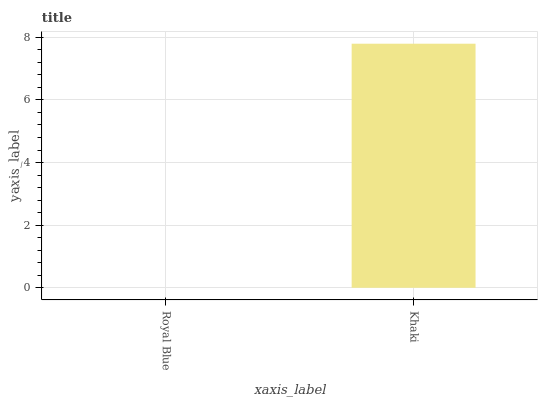Is Royal Blue the minimum?
Answer yes or no. Yes. Is Khaki the maximum?
Answer yes or no. Yes. Is Khaki the minimum?
Answer yes or no. No. Is Khaki greater than Royal Blue?
Answer yes or no. Yes. Is Royal Blue less than Khaki?
Answer yes or no. Yes. Is Royal Blue greater than Khaki?
Answer yes or no. No. Is Khaki less than Royal Blue?
Answer yes or no. No. Is Khaki the high median?
Answer yes or no. Yes. Is Royal Blue the low median?
Answer yes or no. Yes. Is Royal Blue the high median?
Answer yes or no. No. Is Khaki the low median?
Answer yes or no. No. 